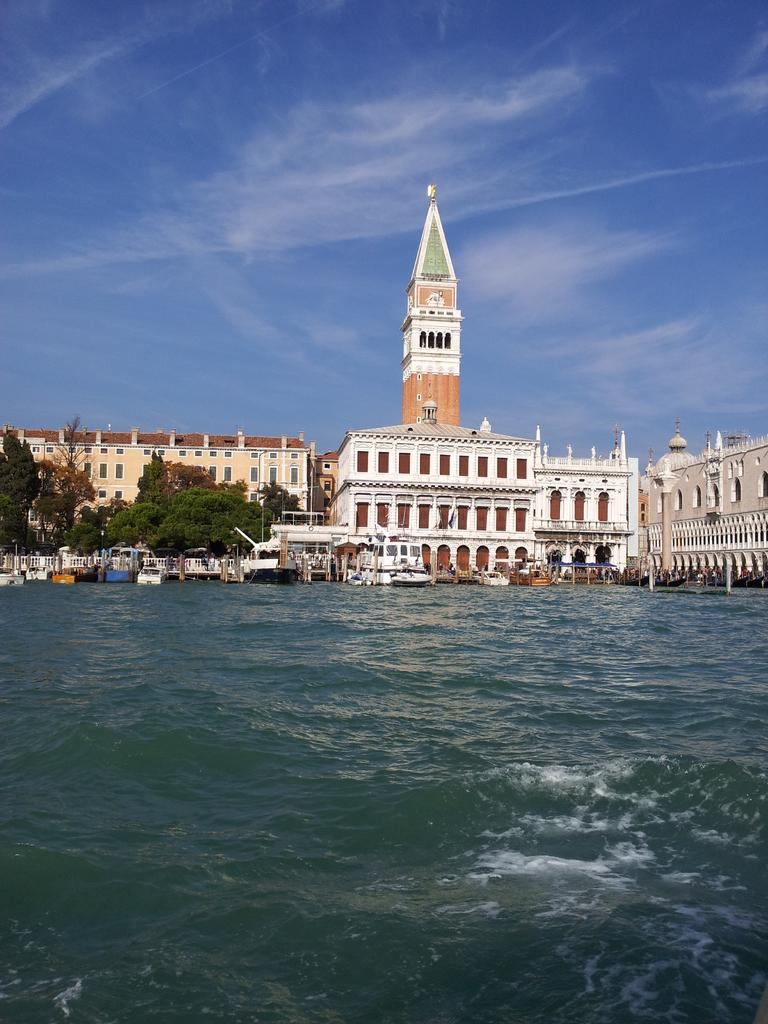What type of body of water is present in the image? There is a lake in the image. What can be seen floating on the lake? There are boats in the image. What type of vegetation is present in the image? There are trees in the image. What type of structures can be seen in the background of the image? There are buildings in the background of the image. What tall structure is present in the image? There is a tower in the image. What is the condition of the sky in the image? The sky is clear in the image. How does the lake express regret in the image? The lake does not express regret in the image, as it is a natural body of water and does not have emotions or the ability to express them. 